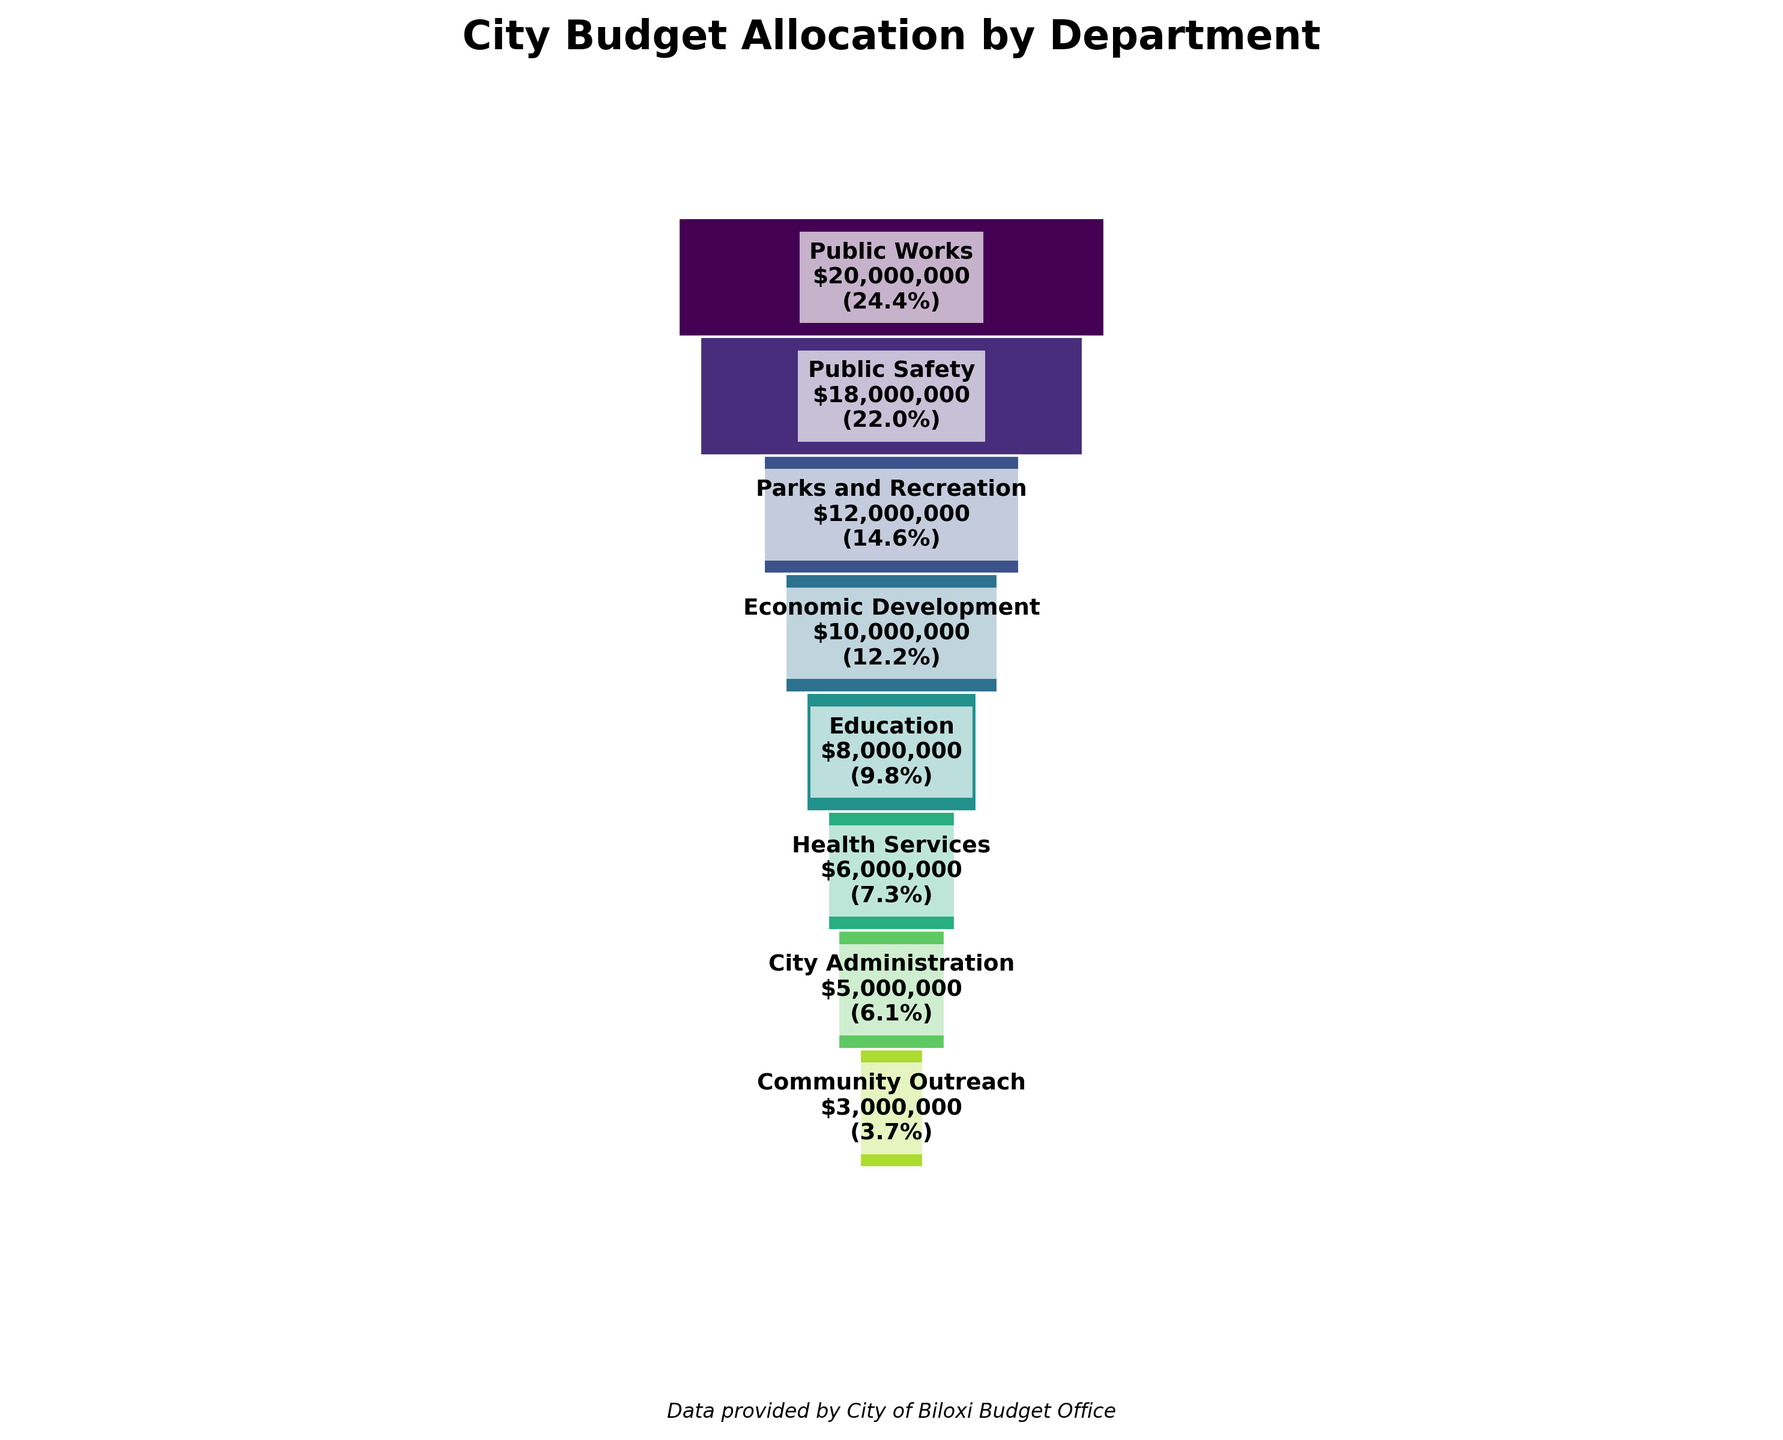What is the title of the funnel chart? The title of the funnel chart is found at the top of the plot, indicating the main topic of the visualization.
Answer: City Budget Allocation by Department Which department has the largest budget allocation? The top segment of the funnel chart represents the department with the largest budget allocation.
Answer: Public Works What is the percentage of the total budget allocated to the Parks and Recreation department? The percentage is written inside the rectangle corresponding to the Parks and Recreation department segment in the funnel chart.
Answer: 12.5% What is the combined budget allocation for Public Works and Public Safety? By adding the budget allocations of Public Works ($20,000,000) and Public Safety ($18,000,000), we can find the combined budget allocation.
Answer: $38,000,000 Which departments have a budget allocation less than $10,000,000? By looking at the segments of the funnel chart, we identify the departments with budget blocks smaller than the remaining segment, which shows the size of their allocations.
Answer: Education, Health Services, City Administration, Community Outreach How does the budget for Education compare to that of Economic Development? Comparing the size and label of the rectangle for Education ($8,000,000) with Economic Development ($10,000,000) shows that Education has a smaller budget.
Answer: Economic Development has a larger budget than Education Calculate the total budget allocation for the bottom three departments. Summing up the budget allocations for Health Services ($6,000,000), City Administration ($5,000,000), and Community Outreach ($3,000,000) will give the total for the bottom three departments.
Answer: $14,000,000 Which department has the smallest budget allocation, and what is the value? The bottom segment of the funnel chart, which is the smallest and labeled as such, shows the department and its budget.
Answer: Community Outreach, $3,000,000 If the budget for Public Safety was increased by $2,000,000, how would its percentage of the total budget change? The new budget for Public Safety would be $20,000,000. The total budget would be $71,000,000. Calculate the new percentage as (20,000,000 / 71,000,000) * 100. 20/71*100 = 28.2%
Answer: 28.2% Which department represents approximately one-sixth of the total budget allocation? Calculate one-sixth of the total budget ($66,000,000), and identify the department with a budget closest to this value. (66,000,000 / 6 ≈ $11,000,000). The closest budget is Parks and Recreation ($12,000,000).
Answer: Parks and Recreation 